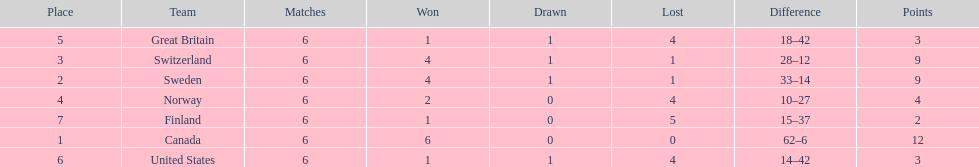What was the number of points won by great britain? 3. 